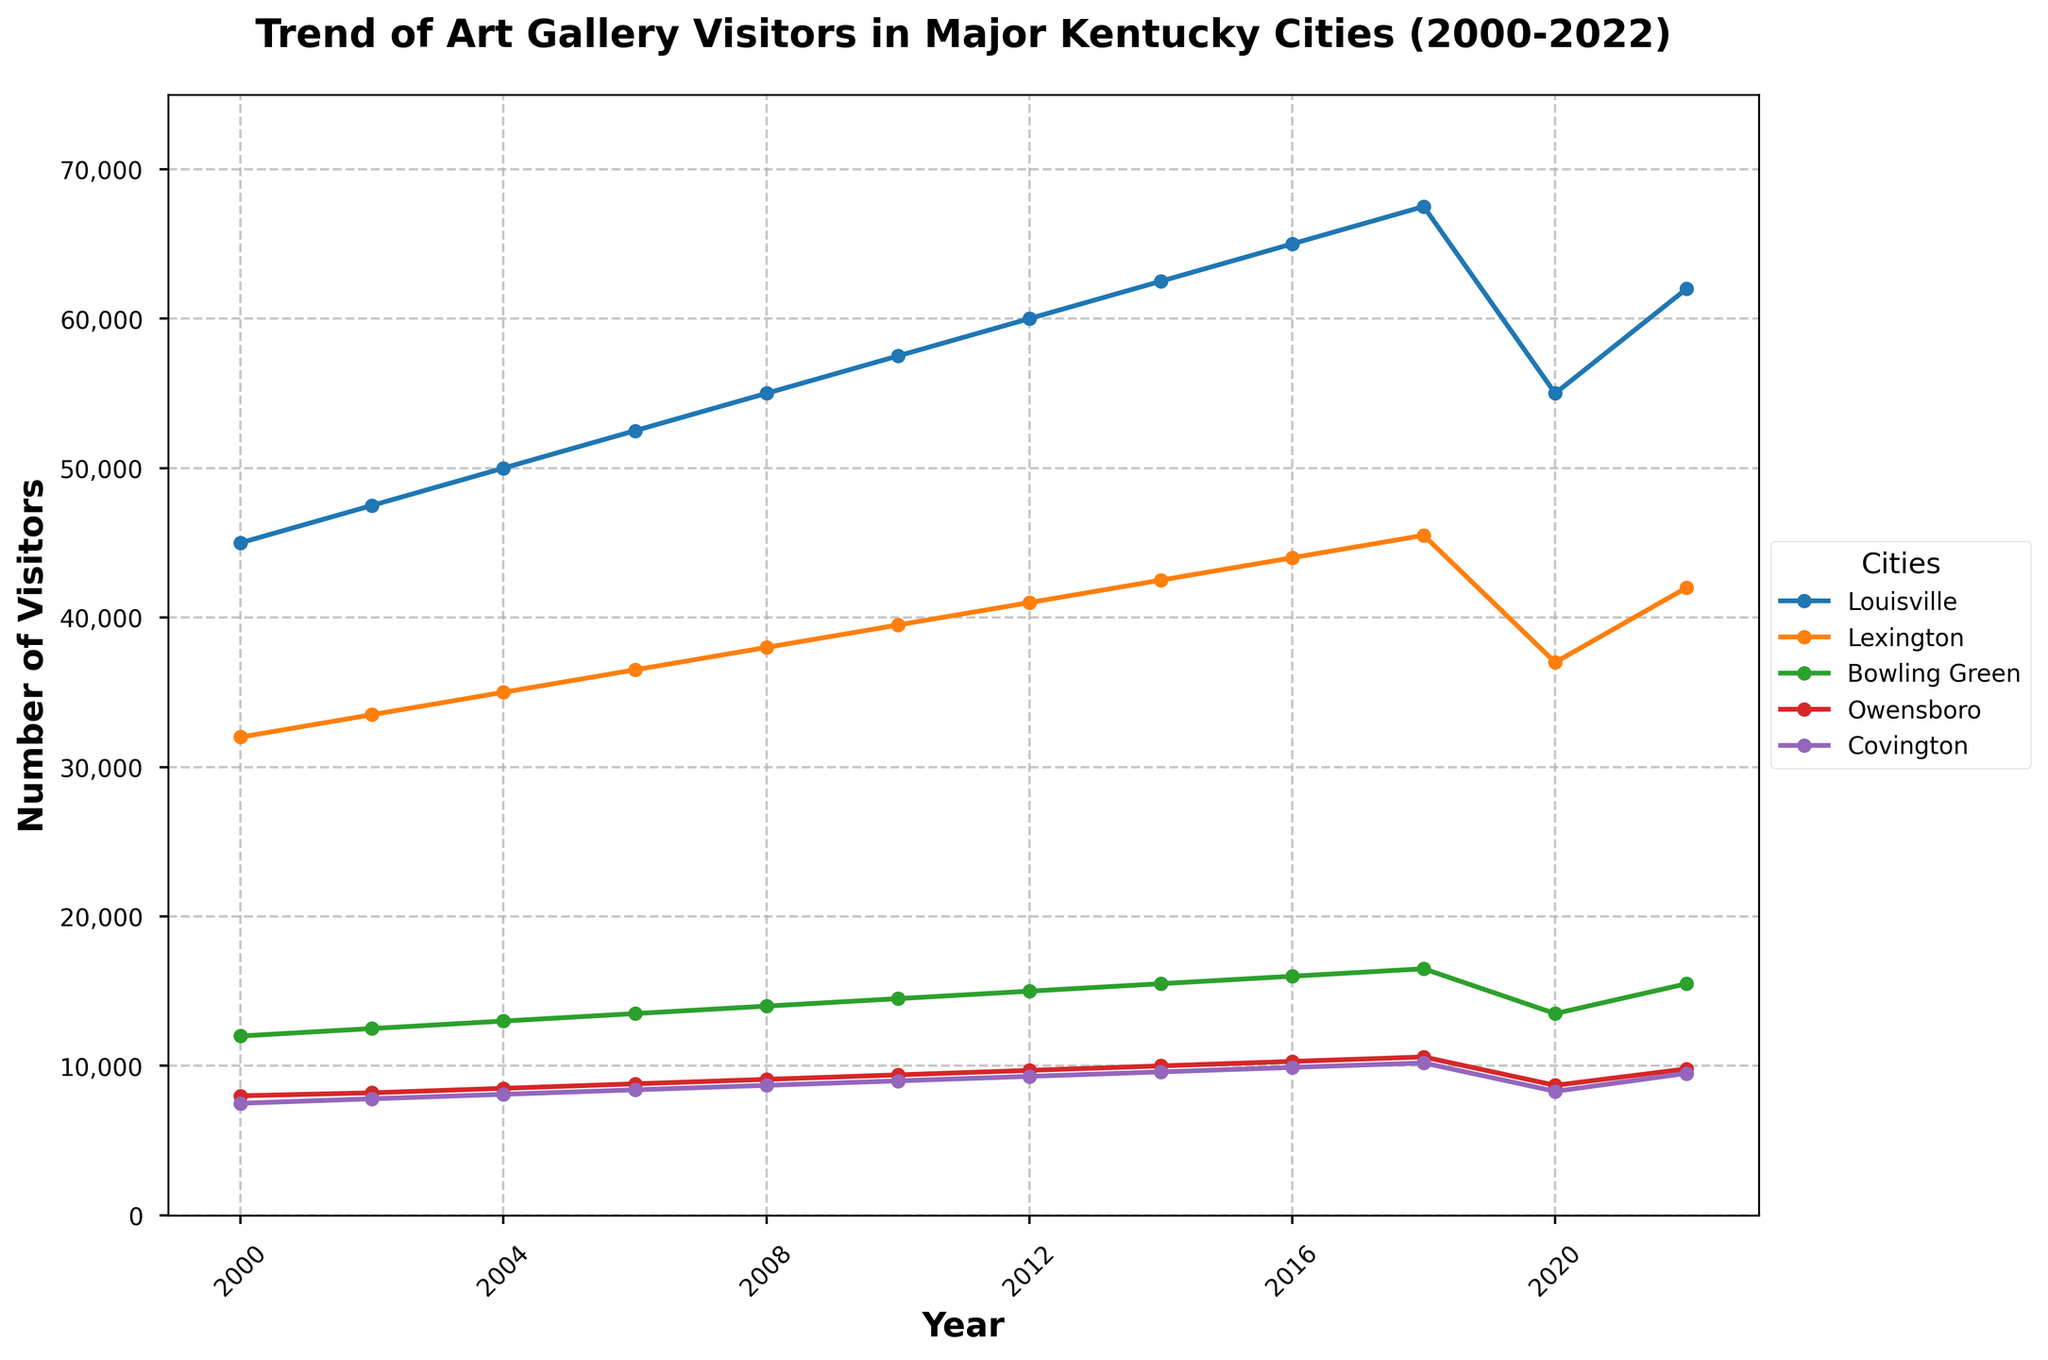What's the overall trend of visitors in Louisville from 2000 to 2022? The overall trend in Louisville shows a steady increase in the number of visitors from 2000 to 2018, a significant drop in 2020, and a rise again by 2022. This suggests an overall upward trend with a pandemic-related dip in 2020.
Answer: Increasing Which city had the highest number of visitors across all years? Louisville consistently had the highest number of visitors each year from 2000 to 2022.
Answer: Louisville What was the difference in the number of visitors between Lexington and Bowling Green in 2022? In 2022, Lexington had 42,000 visitors, and Bowling Green had 15,500 visitors. The difference is calculated as 42,000 - 15,500 = 26,500.
Answer: 26,500 In which year did Owensboro see the highest number of visitors? Owensboro saw the highest number of visitors in 2022 with 9,800 visitors.
Answer: 2022 How did the number of visitors in Covington change from 2018 to 2022? In 2018, Covington had 10,200 visitors, and in 2022, it had 9,500 visitors. The number decreased by 10,200 - 9,500 = 700.
Answer: Decreased by 700 By how much did the number of visitors in Bowling Green increase from 2000 to 2016? In 2000, Bowling Green had 12,000 visitors, and in 2016, it had 16,000 visitors. The increase is calculated as 16,000 - 12,000 = 4,000.
Answer: 4,000 Which city experienced the steepest decline in visitors between 2018 and 2020? The difference for each city is as follows: Louisville (67,500 to 55,000 = 12,500), Lexington (45,500 to 37,000 = 8,500), Bowling Green (16,500 to 13,500 = 3,000), Owensboro (10,600 to 8,700 = 1,900), Covington (10,200 to 8,300 = 1,900). Louisville experienced the steepest decline.
Answer: Louisville What's the average number of visitors to Lexington from 2000 to 2022? The visitors from 2000 to 2022 are: 32,000, 33,500, 35,000, 36,500, 38,000, 39,500, 41,000, 42,500, 44,000, 45,500, 37,000, 42,000. Summing these values gives 467,500. Dividing by 12 years, the average is 467,500 / 12 ≈ 38,958.
Answer: ≈ 38,958 Which city had the smallest increase in visitors from 2000 to 2022? The increases for each city are: Louisville (62,000 - 45,000 = 17,000), Lexington (42,000 - 32,000 = 10,000), Bowling Green (15,500 - 12,000 = 3,500), Owensboro (9,800 - 8,000 = 1,800), Covington (9,500 - 7,500 = 2,000). Owensboro had the smallest increase.
Answer: Owensboro 